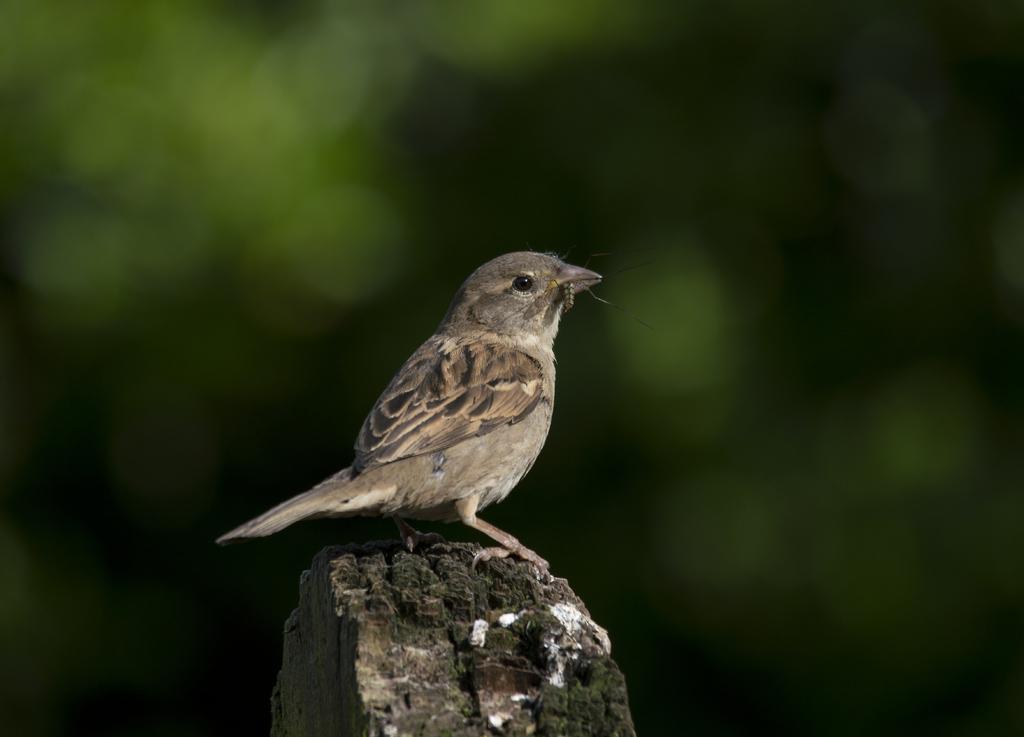Can you describe this image briefly? There is a sparrow and the background is blurred. 